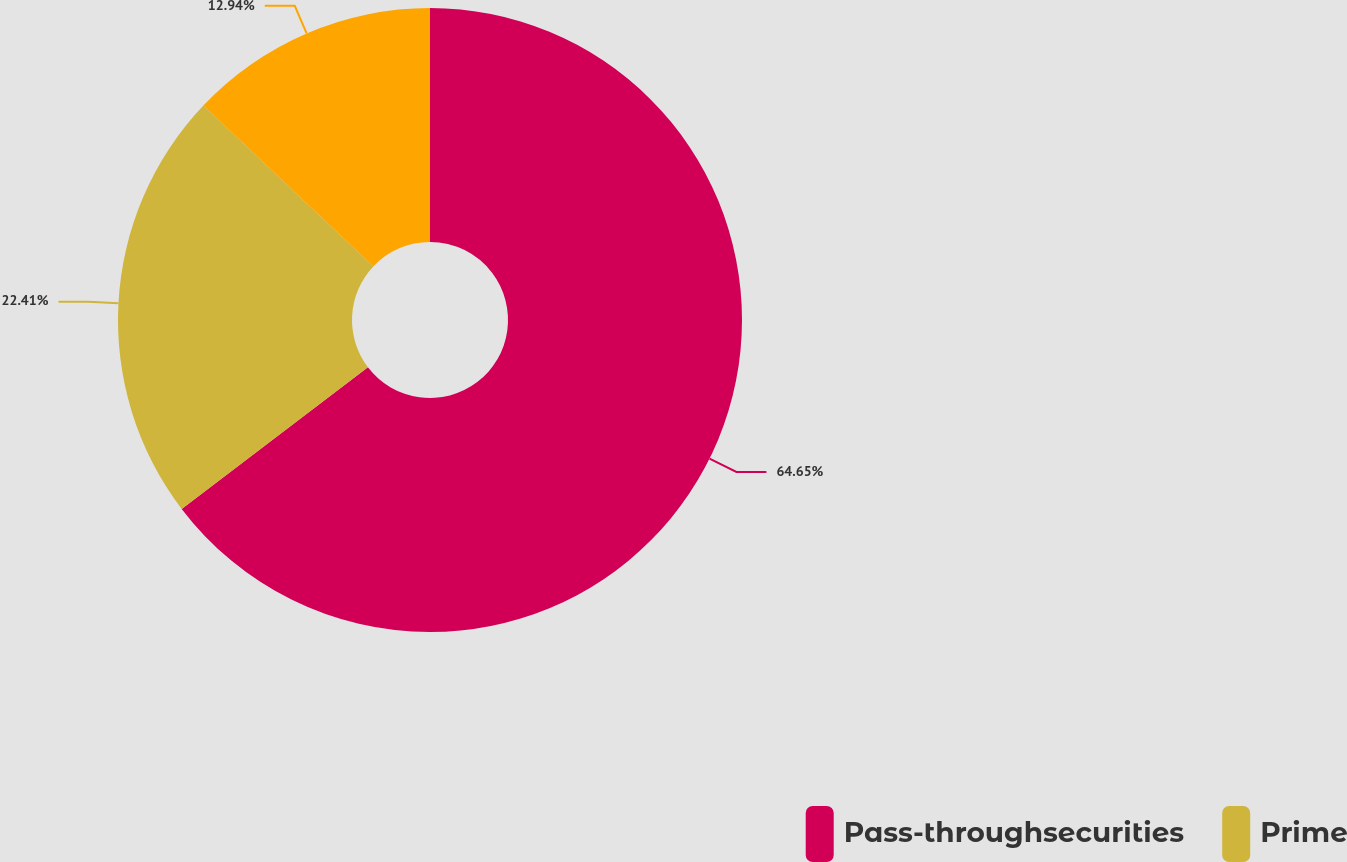Convert chart. <chart><loc_0><loc_0><loc_500><loc_500><pie_chart><fcel>Pass-throughsecurities<fcel>Prime<fcel>Unnamed: 2<nl><fcel>64.65%<fcel>22.41%<fcel>12.94%<nl></chart> 